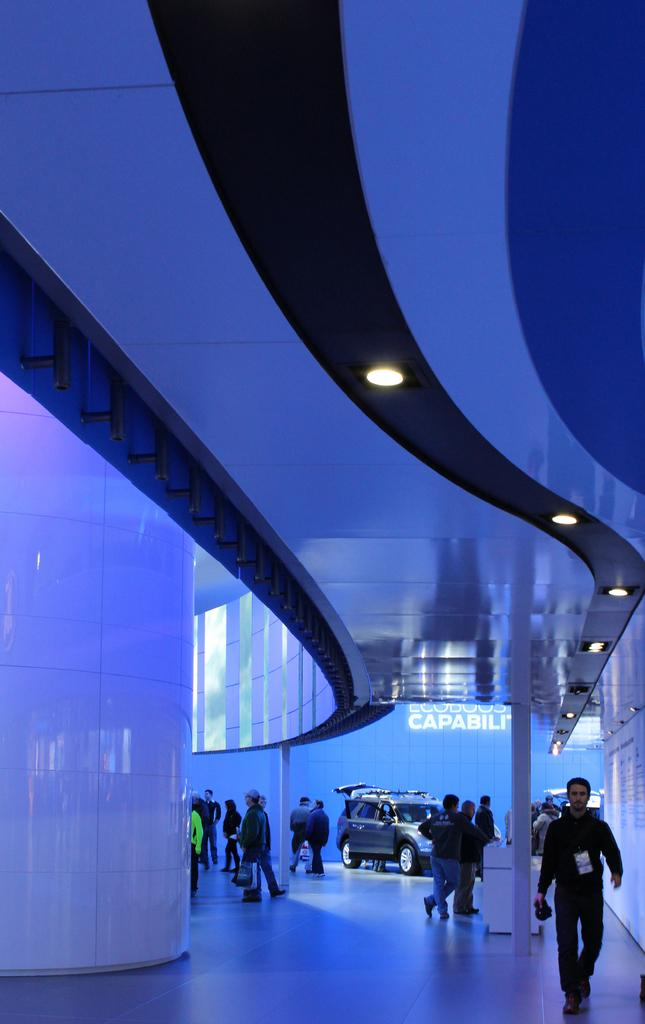What is happening with the group of people in the image? The people are walking in a building. Can you describe the setting of the image? The people are walking in a building, and there is a car visible in the background. Where is the car located in relation to the people? The car is in the background of the image. What is the position of the car in the image? The car is on the ground. What type of agreement is being signed by the duck in the image? There is no duck present in the image, and therefore no agreement being signed. 